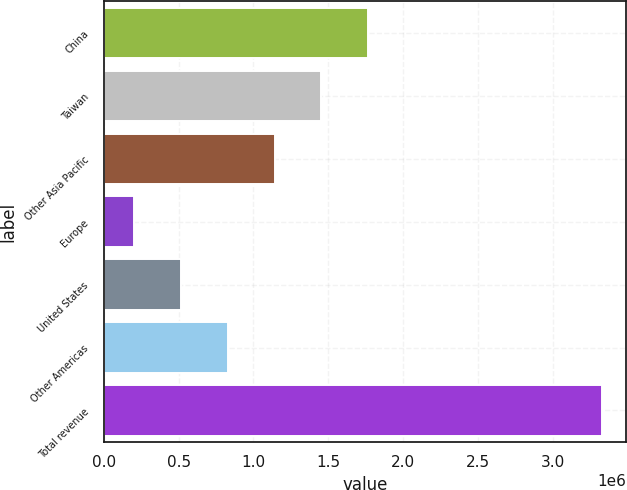Convert chart to OTSL. <chart><loc_0><loc_0><loc_500><loc_500><bar_chart><fcel>China<fcel>Taiwan<fcel>Other Asia Pacific<fcel>Europe<fcel>United States<fcel>Other Americas<fcel>Total revenue<nl><fcel>1.7651e+06<fcel>1.45283e+06<fcel>1.14057e+06<fcel>203760<fcel>516028<fcel>828297<fcel>3.32644e+06<nl></chart> 